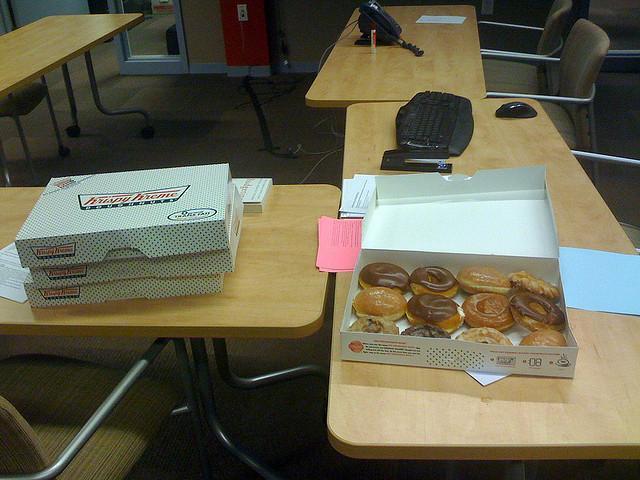Who is a competitor of this company?
Select the accurate response from the four choices given to answer the question.
Options: Dunkin donuts, nathans, office max, home depot. Dunkin donuts. 